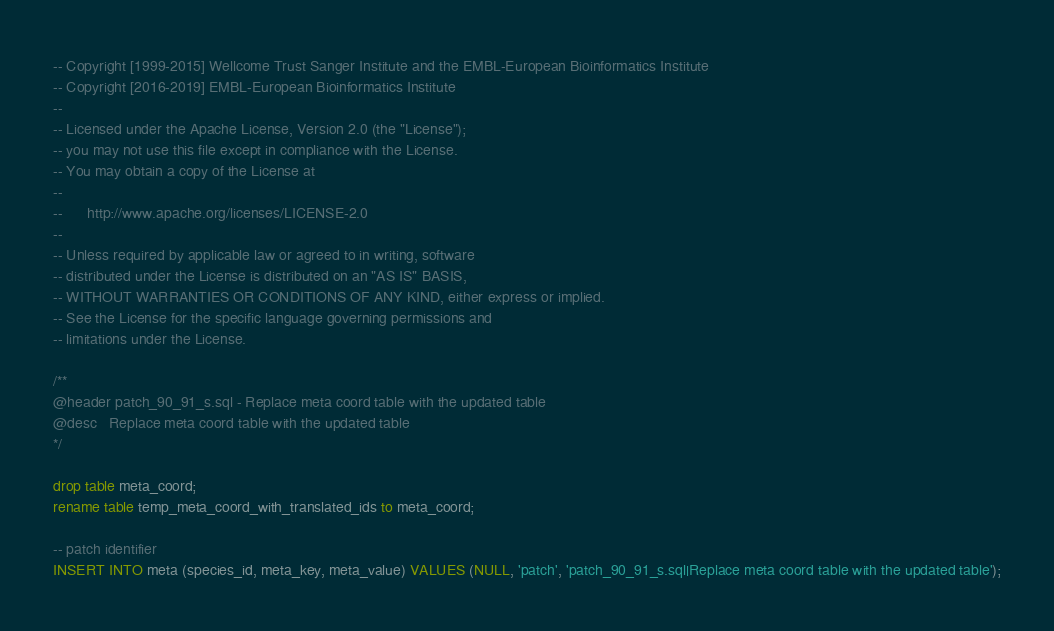<code> <loc_0><loc_0><loc_500><loc_500><_SQL_>-- Copyright [1999-2015] Wellcome Trust Sanger Institute and the EMBL-European Bioinformatics Institute
-- Copyright [2016-2019] EMBL-European Bioinformatics Institute
--
-- Licensed under the Apache License, Version 2.0 (the "License");
-- you may not use this file except in compliance with the License.
-- You may obtain a copy of the License at
--
--      http://www.apache.org/licenses/LICENSE-2.0
--
-- Unless required by applicable law or agreed to in writing, software
-- distributed under the License is distributed on an "AS IS" BASIS,
-- WITHOUT WARRANTIES OR CONDITIONS OF ANY KIND, either express or implied.
-- See the License for the specific language governing permissions and
-- limitations under the License.

/**
@header patch_90_91_s.sql - Replace meta coord table with the updated table
@desc   Replace meta coord table with the updated table
*/

drop table meta_coord;
rename table temp_meta_coord_with_translated_ids to meta_coord;

-- patch identifier
INSERT INTO meta (species_id, meta_key, meta_value) VALUES (NULL, 'patch', 'patch_90_91_s.sql|Replace meta coord table with the updated table');
</code> 